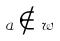<formula> <loc_0><loc_0><loc_500><loc_500>a \notin w</formula> 